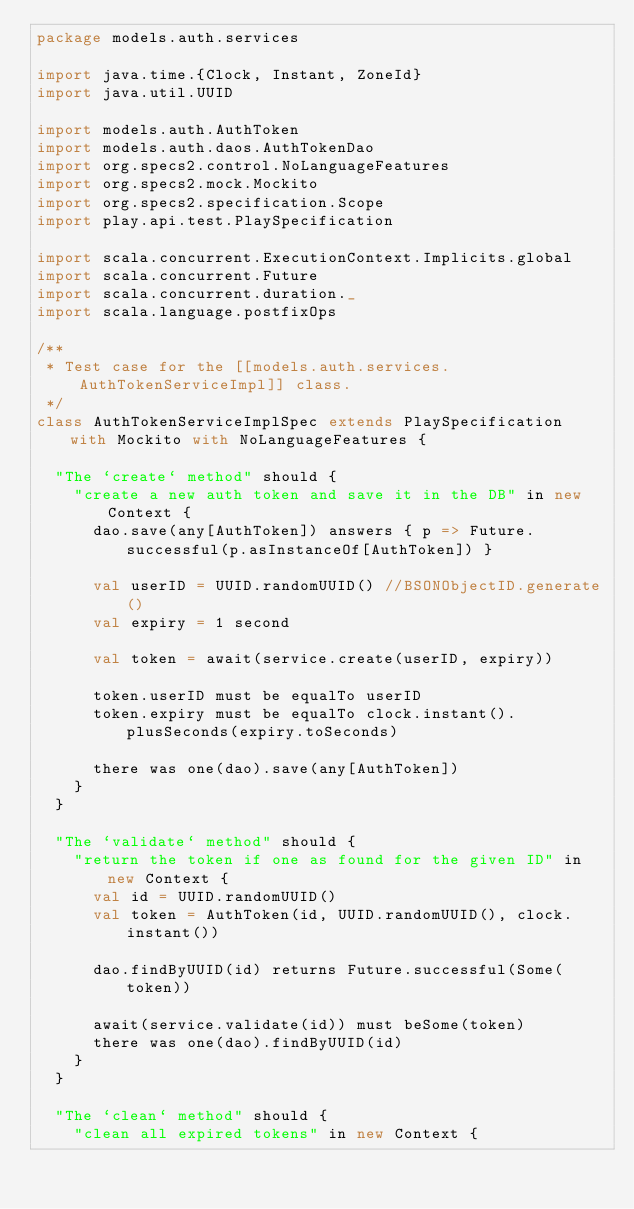<code> <loc_0><loc_0><loc_500><loc_500><_Scala_>package models.auth.services

import java.time.{Clock, Instant, ZoneId}
import java.util.UUID

import models.auth.AuthToken
import models.auth.daos.AuthTokenDao
import org.specs2.control.NoLanguageFeatures
import org.specs2.mock.Mockito
import org.specs2.specification.Scope
import play.api.test.PlaySpecification

import scala.concurrent.ExecutionContext.Implicits.global
import scala.concurrent.Future
import scala.concurrent.duration._
import scala.language.postfixOps

/**
 * Test case for the [[models.auth.services.AuthTokenServiceImpl]] class.
 */
class AuthTokenServiceImplSpec extends PlaySpecification with Mockito with NoLanguageFeatures {

  "The `create` method" should {
    "create a new auth token and save it in the DB" in new Context {
      dao.save(any[AuthToken]) answers { p => Future.successful(p.asInstanceOf[AuthToken]) }

      val userID = UUID.randomUUID() //BSONObjectID.generate()
      val expiry = 1 second

      val token = await(service.create(userID, expiry))

      token.userID must be equalTo userID
      token.expiry must be equalTo clock.instant().plusSeconds(expiry.toSeconds)

      there was one(dao).save(any[AuthToken])
    }
  }

  "The `validate` method" should {
    "return the token if one as found for the given ID" in new Context {
      val id = UUID.randomUUID()
      val token = AuthToken(id, UUID.randomUUID(), clock.instant())

      dao.findByUUID(id) returns Future.successful(Some(token))

      await(service.validate(id)) must beSome(token)
      there was one(dao).findByUUID(id)
    }
  }

  "The `clean` method" should {
    "clean all expired tokens" in new Context {</code> 